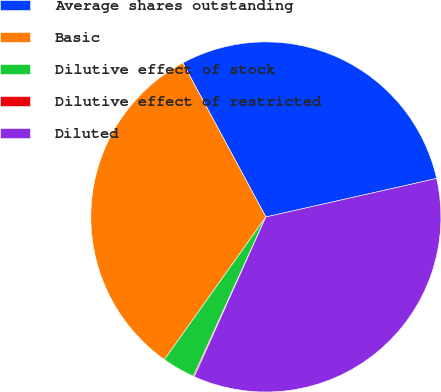<chart> <loc_0><loc_0><loc_500><loc_500><pie_chart><fcel>Average shares outstanding<fcel>Basic<fcel>Dilutive effect of stock<fcel>Dilutive effect of restricted<fcel>Diluted<nl><fcel>29.34%<fcel>32.29%<fcel>3.04%<fcel>0.1%<fcel>35.23%<nl></chart> 